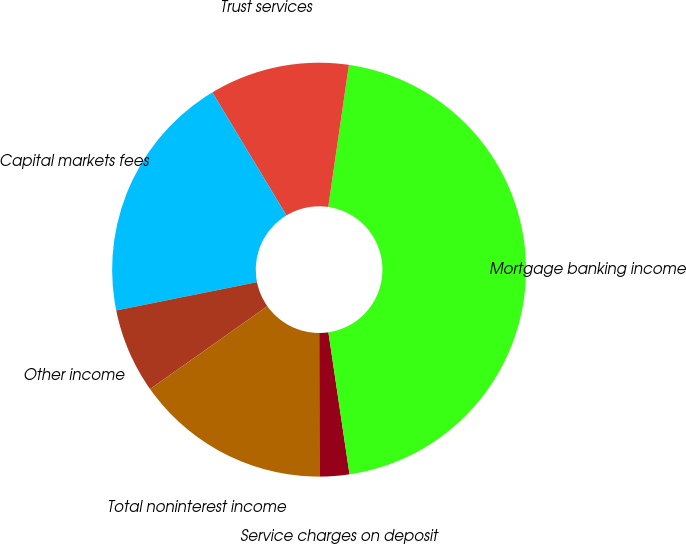Convert chart to OTSL. <chart><loc_0><loc_0><loc_500><loc_500><pie_chart><fcel>Service charges on deposit<fcel>Mortgage banking income<fcel>Trust services<fcel>Capital markets fees<fcel>Other income<fcel>Total noninterest income<nl><fcel>2.33%<fcel>45.35%<fcel>10.93%<fcel>19.53%<fcel>6.63%<fcel>15.23%<nl></chart> 